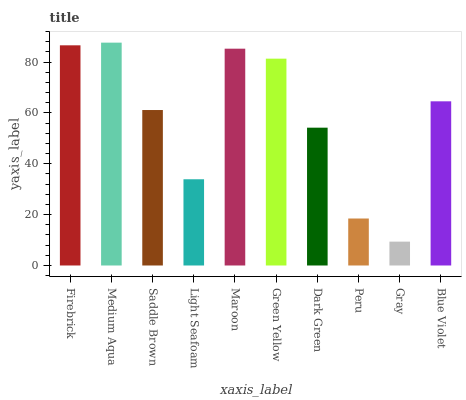Is Gray the minimum?
Answer yes or no. Yes. Is Medium Aqua the maximum?
Answer yes or no. Yes. Is Saddle Brown the minimum?
Answer yes or no. No. Is Saddle Brown the maximum?
Answer yes or no. No. Is Medium Aqua greater than Saddle Brown?
Answer yes or no. Yes. Is Saddle Brown less than Medium Aqua?
Answer yes or no. Yes. Is Saddle Brown greater than Medium Aqua?
Answer yes or no. No. Is Medium Aqua less than Saddle Brown?
Answer yes or no. No. Is Blue Violet the high median?
Answer yes or no. Yes. Is Saddle Brown the low median?
Answer yes or no. Yes. Is Gray the high median?
Answer yes or no. No. Is Firebrick the low median?
Answer yes or no. No. 